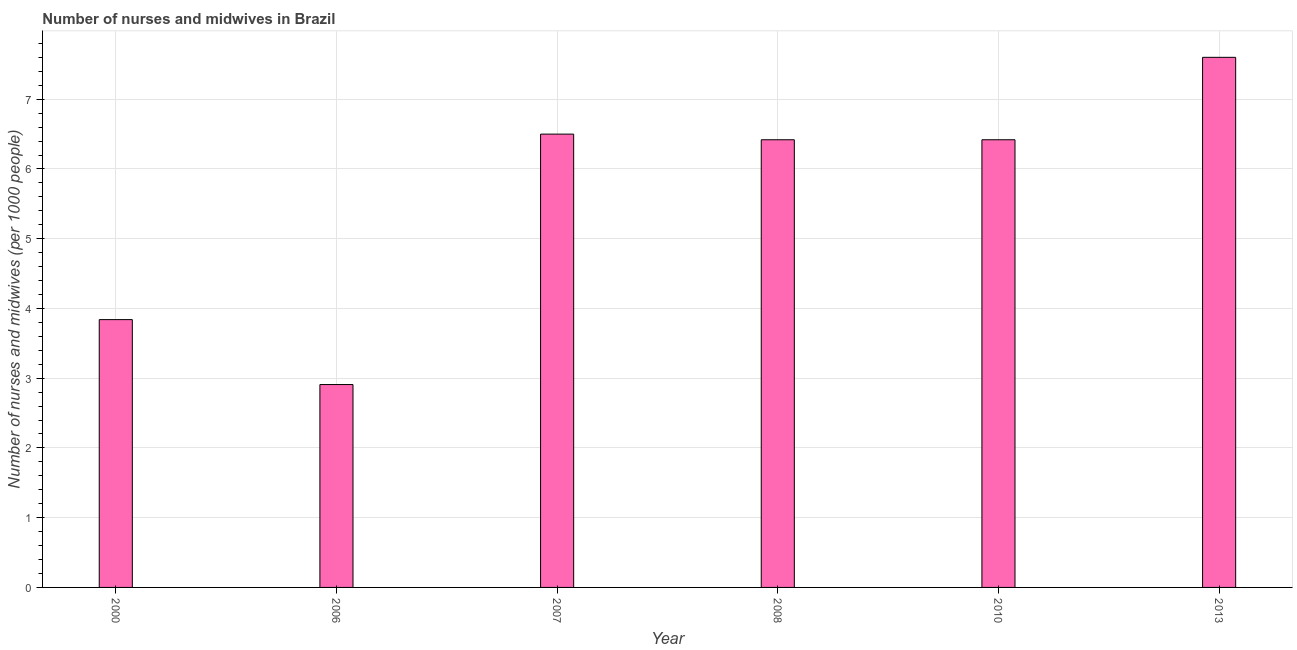Does the graph contain any zero values?
Provide a short and direct response. No. What is the title of the graph?
Your answer should be very brief. Number of nurses and midwives in Brazil. What is the label or title of the X-axis?
Ensure brevity in your answer.  Year. What is the label or title of the Y-axis?
Offer a very short reply. Number of nurses and midwives (per 1000 people). What is the number of nurses and midwives in 2010?
Keep it short and to the point. 6.42. Across all years, what is the maximum number of nurses and midwives?
Provide a succinct answer. 7.6. Across all years, what is the minimum number of nurses and midwives?
Your response must be concise. 2.91. What is the sum of the number of nurses and midwives?
Your answer should be compact. 33.69. What is the difference between the number of nurses and midwives in 2007 and 2008?
Make the answer very short. 0.08. What is the average number of nurses and midwives per year?
Provide a short and direct response. 5.62. What is the median number of nurses and midwives?
Provide a succinct answer. 6.42. Do a majority of the years between 2008 and 2006 (inclusive) have number of nurses and midwives greater than 3.2 ?
Offer a very short reply. Yes. What is the ratio of the number of nurses and midwives in 2006 to that in 2010?
Your answer should be compact. 0.45. Is the number of nurses and midwives in 2006 less than that in 2007?
Ensure brevity in your answer.  Yes. What is the difference between the highest and the second highest number of nurses and midwives?
Your response must be concise. 1.1. Is the sum of the number of nurses and midwives in 2006 and 2007 greater than the maximum number of nurses and midwives across all years?
Provide a short and direct response. Yes. What is the difference between the highest and the lowest number of nurses and midwives?
Provide a succinct answer. 4.69. In how many years, is the number of nurses and midwives greater than the average number of nurses and midwives taken over all years?
Keep it short and to the point. 4. How many bars are there?
Keep it short and to the point. 6. How many years are there in the graph?
Provide a succinct answer. 6. What is the difference between two consecutive major ticks on the Y-axis?
Give a very brief answer. 1. What is the Number of nurses and midwives (per 1000 people) in 2000?
Your answer should be compact. 3.84. What is the Number of nurses and midwives (per 1000 people) in 2006?
Provide a succinct answer. 2.91. What is the Number of nurses and midwives (per 1000 people) in 2007?
Make the answer very short. 6.5. What is the Number of nurses and midwives (per 1000 people) of 2008?
Make the answer very short. 6.42. What is the Number of nurses and midwives (per 1000 people) in 2010?
Give a very brief answer. 6.42. What is the Number of nurses and midwives (per 1000 people) of 2013?
Provide a short and direct response. 7.6. What is the difference between the Number of nurses and midwives (per 1000 people) in 2000 and 2007?
Provide a succinct answer. -2.66. What is the difference between the Number of nurses and midwives (per 1000 people) in 2000 and 2008?
Provide a succinct answer. -2.58. What is the difference between the Number of nurses and midwives (per 1000 people) in 2000 and 2010?
Your answer should be very brief. -2.58. What is the difference between the Number of nurses and midwives (per 1000 people) in 2000 and 2013?
Your response must be concise. -3.76. What is the difference between the Number of nurses and midwives (per 1000 people) in 2006 and 2007?
Keep it short and to the point. -3.59. What is the difference between the Number of nurses and midwives (per 1000 people) in 2006 and 2008?
Your response must be concise. -3.51. What is the difference between the Number of nurses and midwives (per 1000 people) in 2006 and 2010?
Give a very brief answer. -3.51. What is the difference between the Number of nurses and midwives (per 1000 people) in 2006 and 2013?
Give a very brief answer. -4.69. What is the difference between the Number of nurses and midwives (per 1000 people) in 2007 and 2008?
Offer a very short reply. 0.08. What is the difference between the Number of nurses and midwives (per 1000 people) in 2007 and 2010?
Offer a terse response. 0.08. What is the difference between the Number of nurses and midwives (per 1000 people) in 2007 and 2013?
Your response must be concise. -1.1. What is the difference between the Number of nurses and midwives (per 1000 people) in 2008 and 2013?
Offer a terse response. -1.18. What is the difference between the Number of nurses and midwives (per 1000 people) in 2010 and 2013?
Provide a succinct answer. -1.18. What is the ratio of the Number of nurses and midwives (per 1000 people) in 2000 to that in 2006?
Give a very brief answer. 1.32. What is the ratio of the Number of nurses and midwives (per 1000 people) in 2000 to that in 2007?
Your answer should be compact. 0.59. What is the ratio of the Number of nurses and midwives (per 1000 people) in 2000 to that in 2008?
Ensure brevity in your answer.  0.6. What is the ratio of the Number of nurses and midwives (per 1000 people) in 2000 to that in 2010?
Your response must be concise. 0.6. What is the ratio of the Number of nurses and midwives (per 1000 people) in 2000 to that in 2013?
Make the answer very short. 0.51. What is the ratio of the Number of nurses and midwives (per 1000 people) in 2006 to that in 2007?
Make the answer very short. 0.45. What is the ratio of the Number of nurses and midwives (per 1000 people) in 2006 to that in 2008?
Give a very brief answer. 0.45. What is the ratio of the Number of nurses and midwives (per 1000 people) in 2006 to that in 2010?
Provide a succinct answer. 0.45. What is the ratio of the Number of nurses and midwives (per 1000 people) in 2006 to that in 2013?
Your response must be concise. 0.38. What is the ratio of the Number of nurses and midwives (per 1000 people) in 2007 to that in 2008?
Offer a terse response. 1.01. What is the ratio of the Number of nurses and midwives (per 1000 people) in 2007 to that in 2010?
Offer a terse response. 1.01. What is the ratio of the Number of nurses and midwives (per 1000 people) in 2007 to that in 2013?
Provide a succinct answer. 0.85. What is the ratio of the Number of nurses and midwives (per 1000 people) in 2008 to that in 2010?
Offer a very short reply. 1. What is the ratio of the Number of nurses and midwives (per 1000 people) in 2008 to that in 2013?
Provide a succinct answer. 0.84. What is the ratio of the Number of nurses and midwives (per 1000 people) in 2010 to that in 2013?
Offer a terse response. 0.84. 